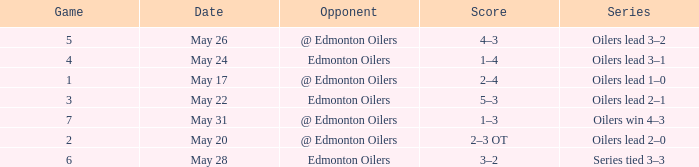Opponent of @ edmonton oilers, and a Game smaller than 7, and a Series of oilers lead 3–2 had what score? 4–3. 